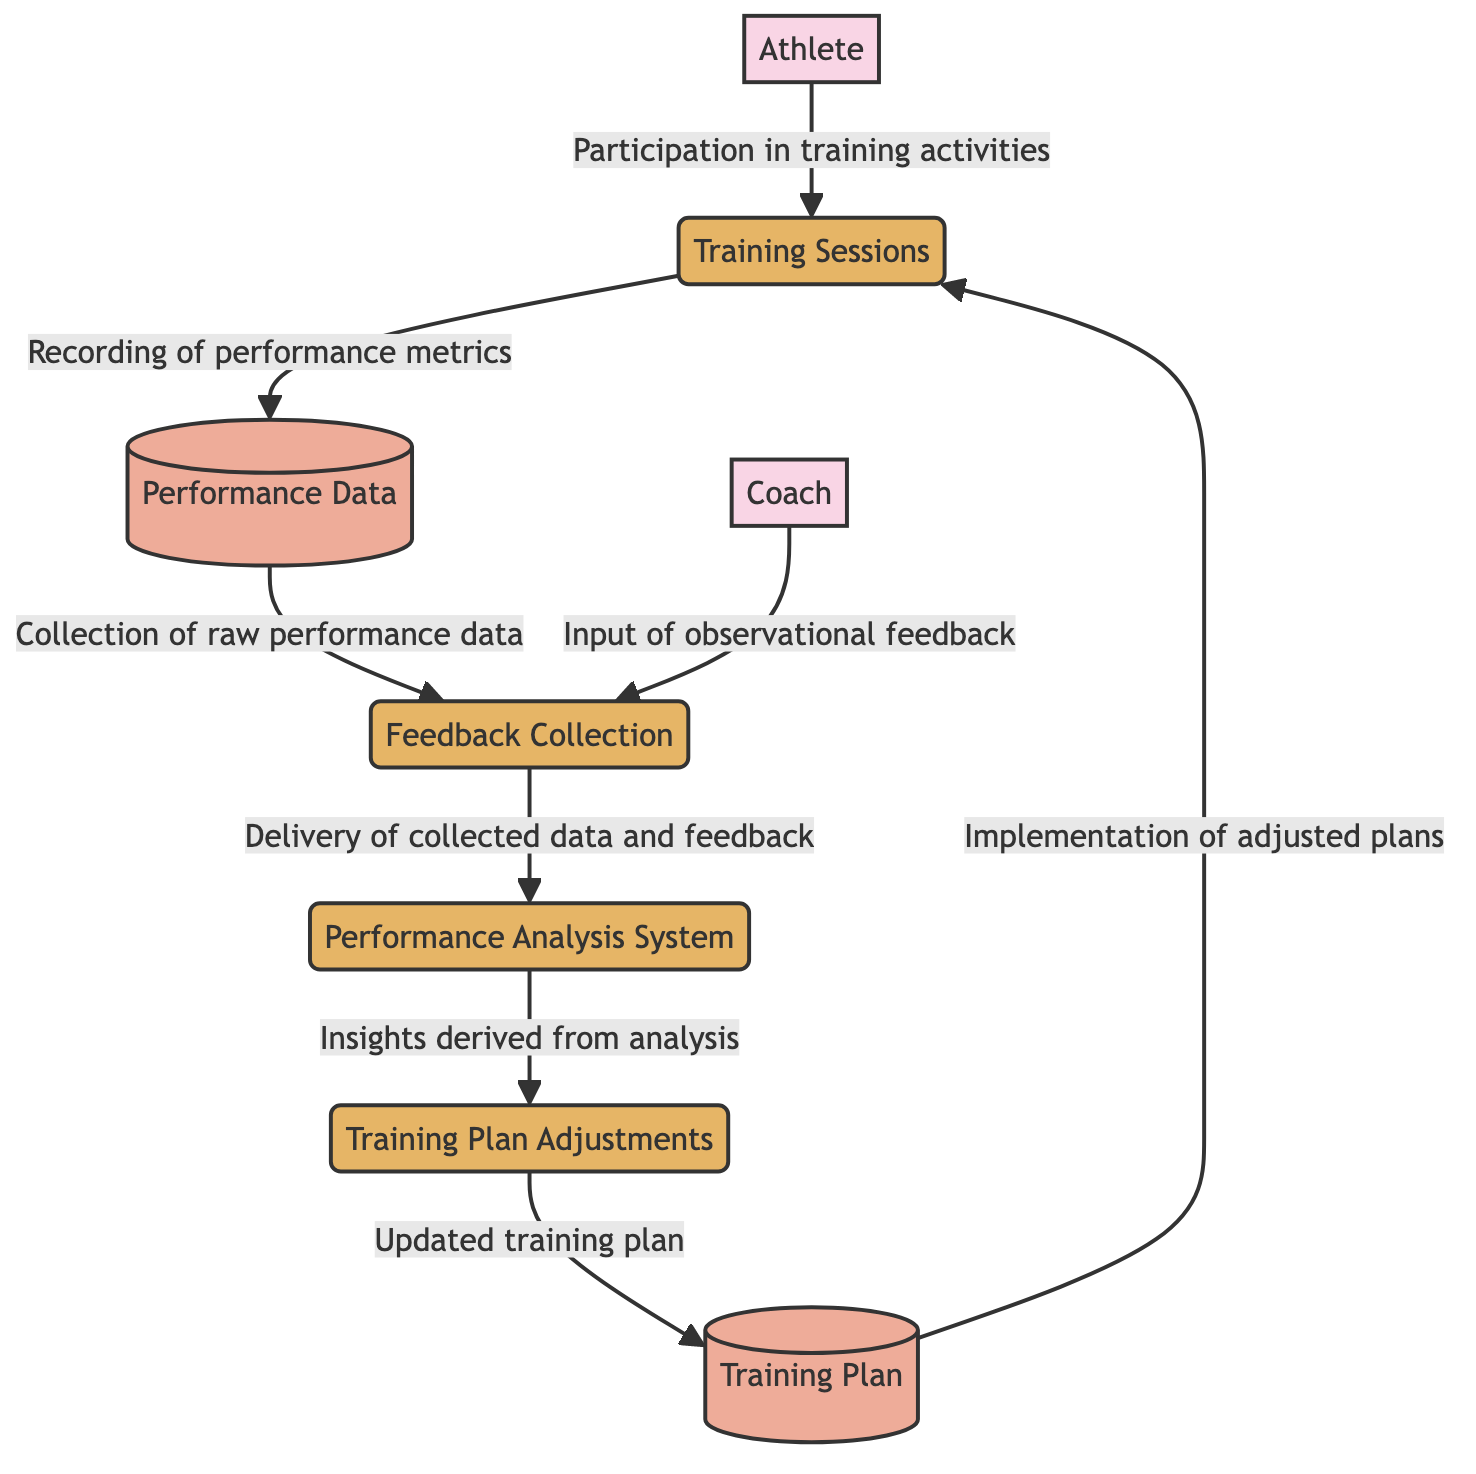What is the first entity in the data flow? The first entity in the diagram is "Athlete," which represents the individual participating in training activities.
Answer: Athlete How many processes are there in the diagram? There are four processes in the diagram: Feedback Collection, Performance Analysis System, Training Plan Adjustments, and Training Sessions.
Answer: Four What type of entity is "Performance Data"? "Performance Data" is classified as a data store in the diagram. Data stores are used to hold information that can be retrieved and used in various processes.
Answer: Data store Which process collects observational feedback from the coach? The "Feedback Collection" process collects observational feedback from the coach, as indicated by the arrow from the Coach to Feedback Collection.
Answer: Feedback Collection What does "Training Plan Adjustments" provide to "Training Plan"? "Training Plan Adjustments" provides an "Updated training plan" to the "Training Plan," indicating that modifications are made based on performance insights.
Answer: Updated training plan How does the flow of information start in this loop? The flow of information starts with the "Athlete," who participates in "Training Sessions," marking the beginning of the training feedback loop in the diagram.
Answer: Athlete What is stored in the "Performance Data"? The "Performance Data" stores raw performance metrics gathered during the training sessions. This includes information like speed, stamina, and accuracy.
Answer: Raw performance metrics Which external entity inputs data into "Feedback Collection"? The external entity that inputs data into "Feedback Collection" is the "Coach," who provides observational feedback regarding the athlete's performance.
Answer: Coach What is the final process that takes place before implementing the training plan? The final process before implementing the training plan is "Training Plan Adjustments," which modifies the training plan based on the insights derived from performance analysis.
Answer: Training Plan Adjustments What comes after "Performance Analysis System" in the data flow? After "Performance Analysis System," the next step is "Training Plan Adjustments," where insights derived from the analysis are used to update training plans.
Answer: Training Plan Adjustments 